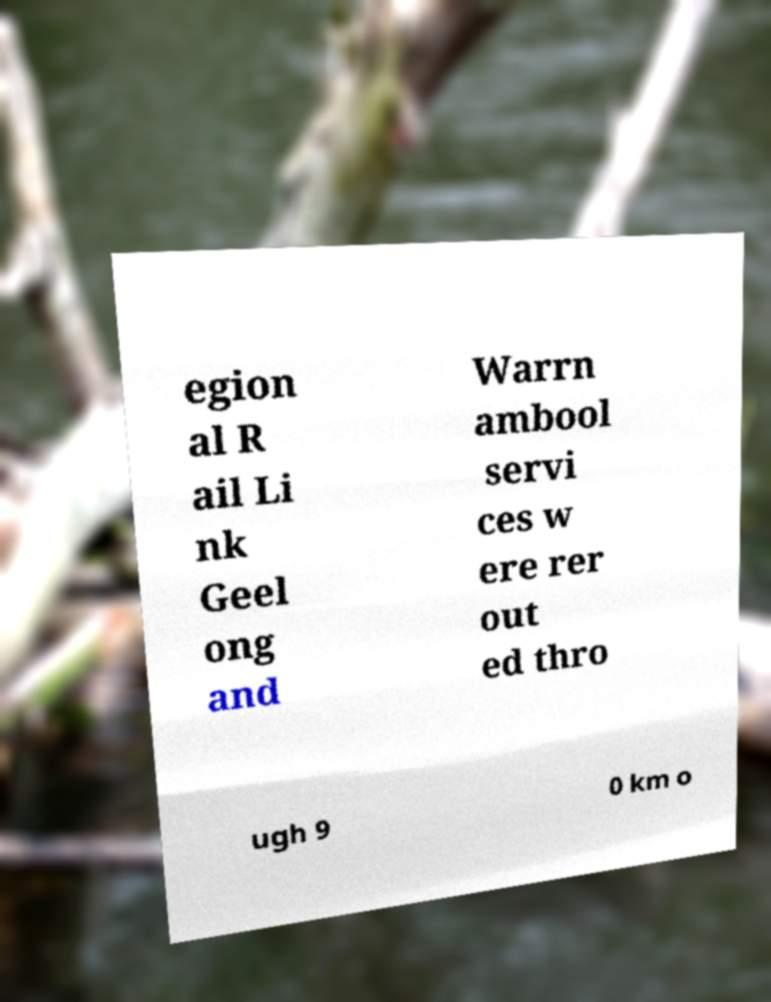There's text embedded in this image that I need extracted. Can you transcribe it verbatim? egion al R ail Li nk Geel ong and Warrn ambool servi ces w ere rer out ed thro ugh 9 0 km o 